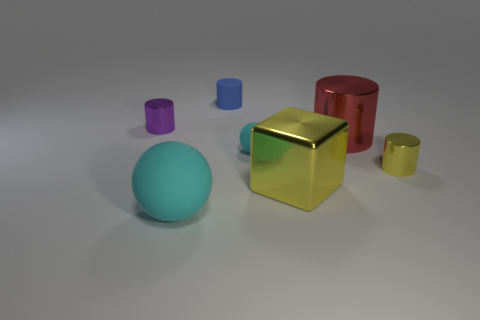What might be the significance of the varying sizes and colours of the objects? The different sizes may represent a hierarchical scale or provide a sense of depth within the scene. The diverse colours could symbolize diversity or individuality, and when assembled together, they create a harmonious and balanced composition despite their differences. 